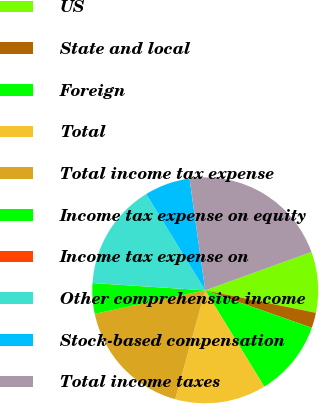Convert chart. <chart><loc_0><loc_0><loc_500><loc_500><pie_chart><fcel>US<fcel>State and local<fcel>Foreign<fcel>Total<fcel>Total income tax expense<fcel>Income tax expense on equity<fcel>Income tax expense on<fcel>Other comprehensive income<fcel>Stock-based compensation<fcel>Total income taxes<nl><fcel>8.7%<fcel>2.19%<fcel>10.87%<fcel>13.04%<fcel>17.38%<fcel>4.36%<fcel>0.02%<fcel>15.21%<fcel>6.53%<fcel>21.72%<nl></chart> 